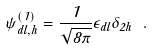<formula> <loc_0><loc_0><loc_500><loc_500>\psi ^ { ( 1 ) } _ { d l , h } = \frac { 1 } { \sqrt { 8 \pi } } \epsilon _ { d l } \delta _ { 2 h } \ .</formula> 